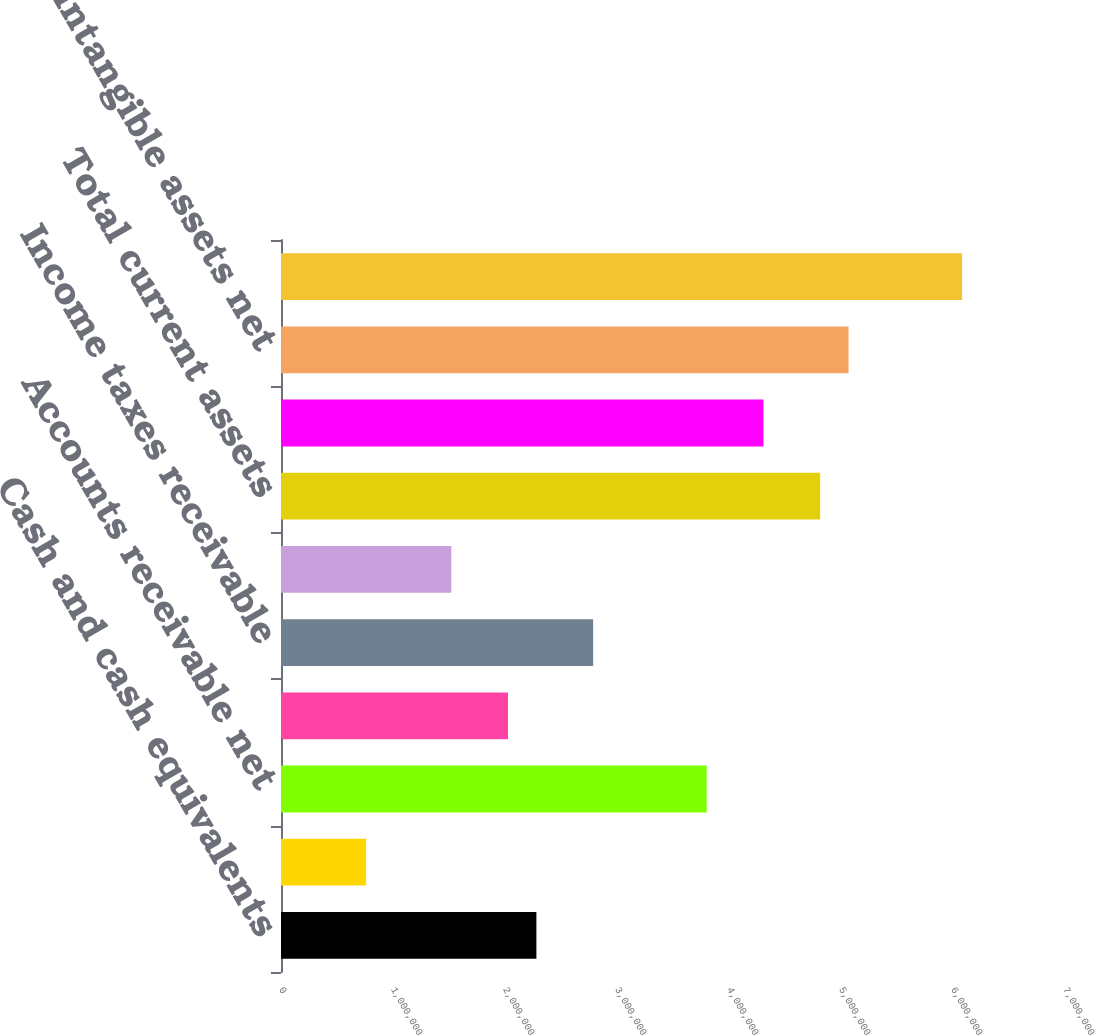Convert chart to OTSL. <chart><loc_0><loc_0><loc_500><loc_500><bar_chart><fcel>Cash and cash equivalents<fcel>Available-for-sale securities<fcel>Accounts receivable net<fcel>Prepaid expenses<fcel>Income taxes receivable<fcel>Other current assets<fcel>Total current assets<fcel>Fixed assets net<fcel>Intangible assets net<fcel>Goodwill<nl><fcel>2.2804e+06<fcel>760225<fcel>3.80058e+06<fcel>2.02704e+06<fcel>2.78713e+06<fcel>1.52031e+06<fcel>4.81403e+06<fcel>4.3073e+06<fcel>5.06739e+06<fcel>6.08084e+06<nl></chart> 